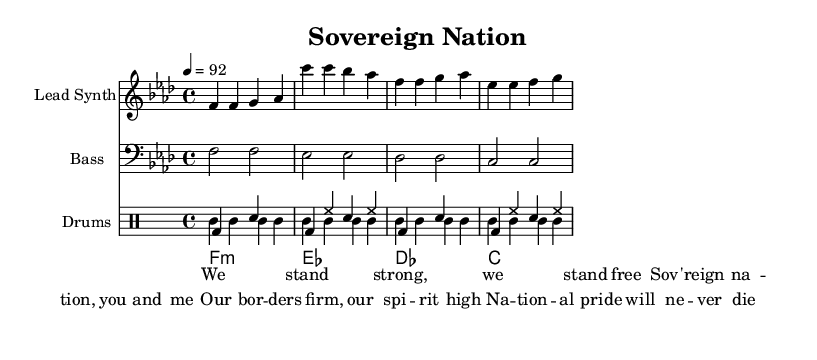What is the key signature of this music? The key signature in this sheet music is F minor, as indicated at the beginning of the score. In F minor, there are four flats.
Answer: F minor What is the time signature of this music? The time signature is shown at the beginning of the score and indicates that there are four beats in each measure, which is expressed as 4/4.
Answer: 4/4 What is the tempo of the music? The tempo marking indicates that the piece should be played at a speed of 92 beats per minute, which is found just above the staff.
Answer: 92 What is the first note of the lead synth line? The first note of the lead synth line is the note F, which is clearly marked in the score at the beginning of the melodic line.
Answer: F How many measures are there in the lead synth part? By counting the vertical lines (bar lines) in the lead synth part, we see that there are four measures. Each measure ends with a bar line.
Answer: 4 What lyrical theme is being expressed in the song? The lyrics indicate a theme of national pride and sovereignty, which is expressed through phrases emphasizing strength and unity among the people of the nation.
Answer: National pride and sovereignty What type of instruments are used in this piece? The sheet music indicates three types of instruments: the lead synth, bass, and drums, each listed at the beginning of their respective staves.
Answer: Lead synth, bass, drums 